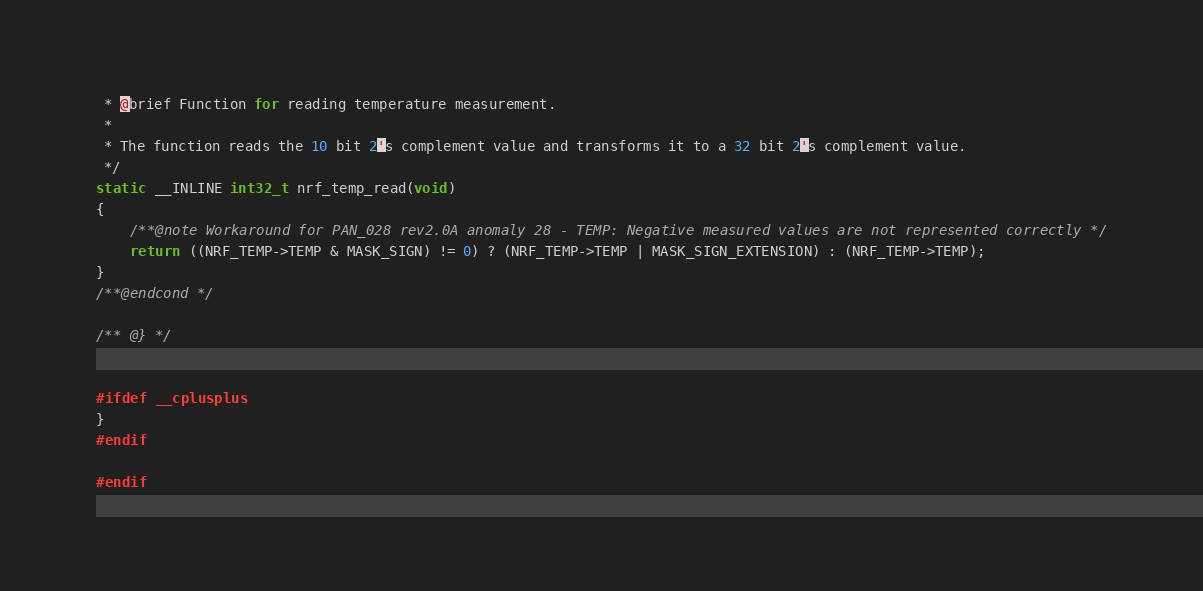<code> <loc_0><loc_0><loc_500><loc_500><_C_> * @brief Function for reading temperature measurement.
 *
 * The function reads the 10 bit 2's complement value and transforms it to a 32 bit 2's complement value.
 */
static __INLINE int32_t nrf_temp_read(void)
{
    /**@note Workaround for PAN_028 rev2.0A anomaly 28 - TEMP: Negative measured values are not represented correctly */
    return ((NRF_TEMP->TEMP & MASK_SIGN) != 0) ? (NRF_TEMP->TEMP | MASK_SIGN_EXTENSION) : (NRF_TEMP->TEMP);
}
/**@endcond */

/** @} */


#ifdef __cplusplus
}
#endif

#endif
</code> 